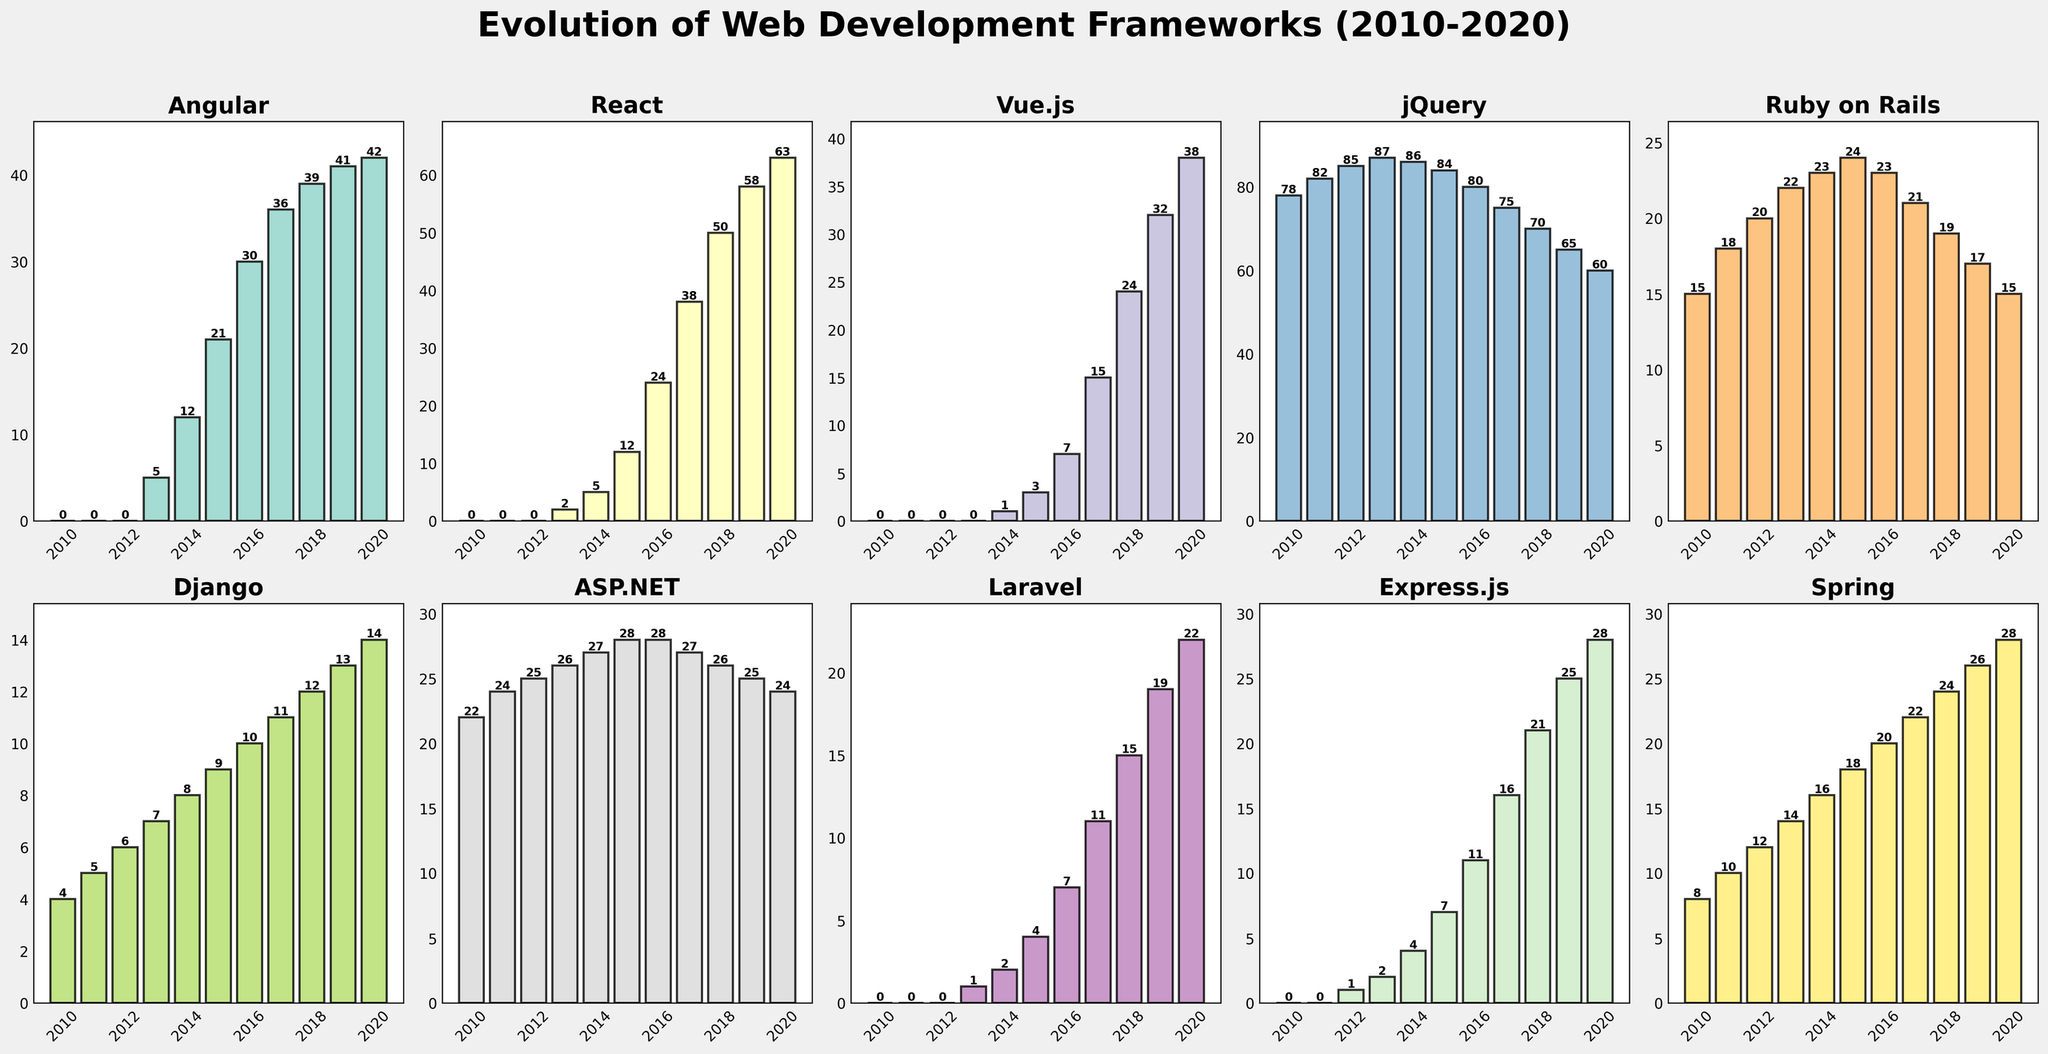Which framework had the highest usage in 2014? By looking at the bar heights for the year 2014, we see that jQuery has the tallest bar among the frameworks. So, jQuery had the highest usage in that year.
Answer: jQuery How did Angular's usage change from 2010 to 2020? From the figure, we can see that Angular's usage started at 0 in 2010, increased gradually over the years, and reached 42 in 2020. This indicates a consistent increase over the decade.
Answer: Increased Which framework showed a consistent increase in usage from 2010 to 2020? By comparing the bar heights year by year, React stands out as a framework that continually increased in usage from 0 in 2010 to 63 in 2020 without any declines.
Answer: React What is the average usage of Vue.js from 2015 to 2020? Taking the values of Vue.js from 2015 to 2020 (3, 7, 15, 24, 32, 38), sum them up to get 119, and then divide by 6 (the number of years). The average usage is \( \frac{119}{6} \approx 19.83 \).
Answer: 19.83 Compare the usage trends of Django and Ruby on Rails between 2010 and 2020. Django shows a steady increase from 4 in 2010 to 14 in 2020. Ruby on Rails shows a different pattern, starting at 15 in 2010 and gradually decreasing to 15 by 2020.
Answer: Django increased steadily, Ruby on Rails decreased In which year did React surpass Angular in usage? Looking at the bar heights for React and Angular over the years, React first surpassed Angular in 2017, where React had a bar height of 38 and Angular had a bar height of 36.
Answer: 2017 Which framework had the least usage overall in 2020? By observing all the bars for 2020, Ruby on Rails had the least height compared to others.
Answer: Ruby on Rails How much did Express.js usage increase from 2016 to 2020? The bar height for Express.js in 2016 is 11 and in 2020 is 28. The increase is \( 28 - 11 = 17 \).
Answer: 17 Which framework(s) show a declining trend at any point between 2010 and 2020? By identifying frameworks whose bar heights decrease over the years, jQuery shows a declining trend starting from a high usage in 2010 and decreasing every year up to 2020.
Answer: jQuery What is the total usage of all frameworks in 2015? Sum the usage for each framework in 2015: (21 + 12 + 3 + 84 + 24 + 9 + 28 + 4 + 7 + 18). This equals 210.
Answer: 210 